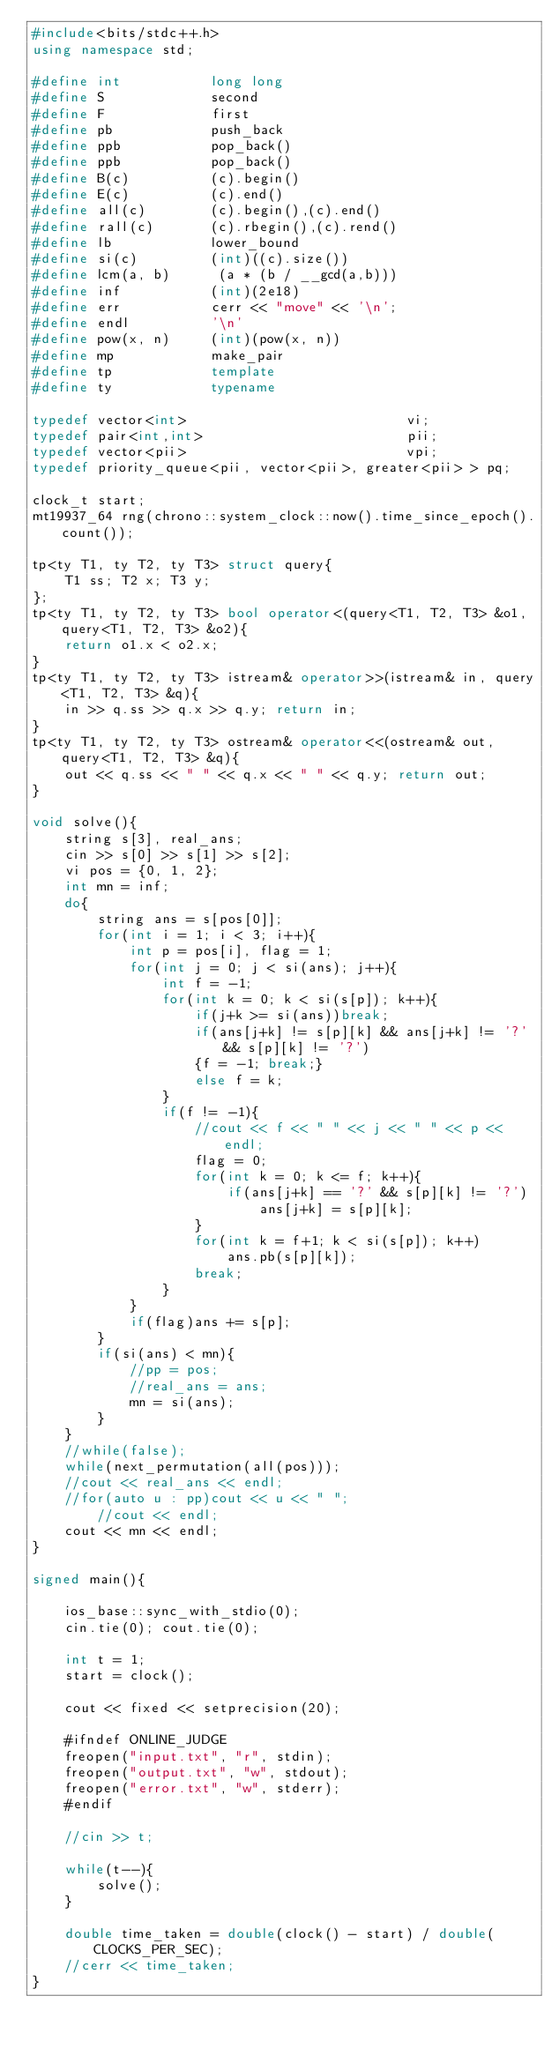Convert code to text. <code><loc_0><loc_0><loc_500><loc_500><_C++_>#include<bits/stdc++.h>
using namespace std;

#define int           long long
#define S             second
#define F             first
#define pb            push_back
#define ppb           pop_back()
#define ppb           pop_back()
#define B(c)          (c).begin()
#define E(c)          (c).end()
#define all(c)        (c).begin(),(c).end()
#define rall(c)       (c).rbegin(),(c).rend() 
#define lb            lower_bound
#define si(c)         (int)((c).size())
#define lcm(a, b)      (a * (b / __gcd(a,b)))  
#define inf           (int)(2e18)
#define err           cerr << "move" << '\n';
#define endl          '\n'
#define pow(x, n)     (int)(pow(x, n))
#define mp            make_pair
#define tp            template
#define ty            typename

typedef vector<int>                           vi;
typedef pair<int,int>                         pii;
typedef vector<pii>                           vpi;
typedef priority_queue<pii, vector<pii>, greater<pii> > pq;

clock_t start;
mt19937_64 rng(chrono::system_clock::now().time_since_epoch().count());

tp<ty T1, ty T2, ty T3> struct query{
    T1 ss; T2 x; T3 y;
};
tp<ty T1, ty T2, ty T3> bool operator<(query<T1, T2, T3> &o1, query<T1, T2, T3> &o2){
    return o1.x < o2.x;
}
tp<ty T1, ty T2, ty T3> istream& operator>>(istream& in, query<T1, T2, T3> &q){
    in >> q.ss >> q.x >> q.y; return in;
}
tp<ty T1, ty T2, ty T3> ostream& operator<<(ostream& out, query<T1, T2, T3> &q){
    out << q.ss << " " << q.x << " " << q.y; return out;
}

void solve(){
	string s[3], real_ans;
	cin >> s[0] >> s[1] >> s[2];
	vi pos = {0, 1, 2};
	int mn = inf;
	do{
		string ans = s[pos[0]];
		for(int i = 1; i < 3; i++){
			int p = pos[i], flag = 1;
			for(int j = 0; j < si(ans); j++){
				int f = -1;
				for(int k = 0; k < si(s[p]); k++){
					if(j+k >= si(ans))break;
					if(ans[j+k] != s[p][k] && ans[j+k] != '?' && s[p][k] != '?')
					{f = -1; break;}
				    else f = k;
				}
				if(f != -1){
					//cout << f << " " << j << " " << p << endl;
					flag = 0;
					for(int k = 0; k <= f; k++){
						if(ans[j+k] == '?' && s[p][k] != '?')
							ans[j+k] = s[p][k];
					}
					for(int k = f+1; k < si(s[p]); k++)
						ans.pb(s[p][k]);
					break;
				}
			}
			if(flag)ans += s[p];
		}
		if(si(ans) < mn){
			//pp = pos;
			//real_ans = ans;
			mn = si(ans);
		}
	}
	//while(false);
	while(next_permutation(all(pos)));
	//cout << real_ans << endl;
	//for(auto u : pp)cout << u << " ";
		//cout << endl;
 	cout << mn << endl;
}

signed main(){

    ios_base::sync_with_stdio(0); 
    cin.tie(0); cout.tie(0);   

    int t = 1;
    start = clock(); 

    cout << fixed << setprecision(20);

    #ifndef ONLINE_JUDGE
    freopen("input.txt", "r", stdin); 
    freopen("output.txt", "w", stdout);
    freopen("error.txt", "w", stderr);
    #endif

    //cin >> t;
    
    while(t--){
        solve();
    }

    double time_taken = double(clock() - start) / double(CLOCKS_PER_SEC); 
    //cerr << time_taken;
}
</code> 